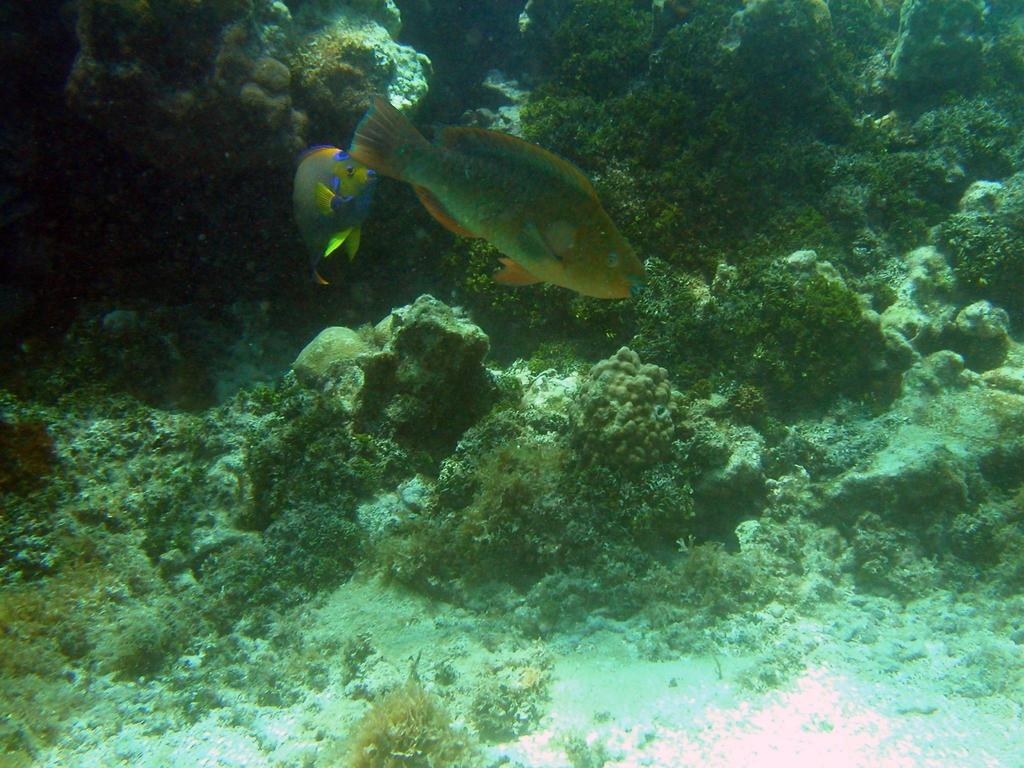What type of animals can be seen in the image? There are fish in the water. What type of underwater environment is visible in the image? There are coral reefs in the image. What type of stew is being cooked in the image? There is no stew present in the image; it features fish and coral reefs in the water. What is the size of the current in the image? There is no current visible in the image, as it focuses on fish and coral reefs in the water. 